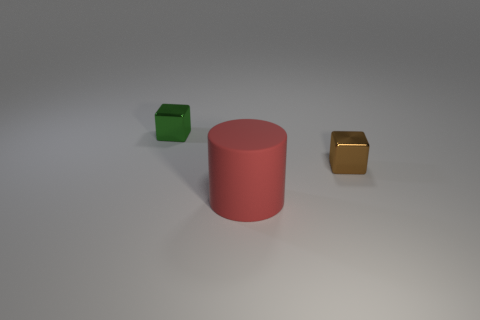What is the shape of the big red thing? cylinder 